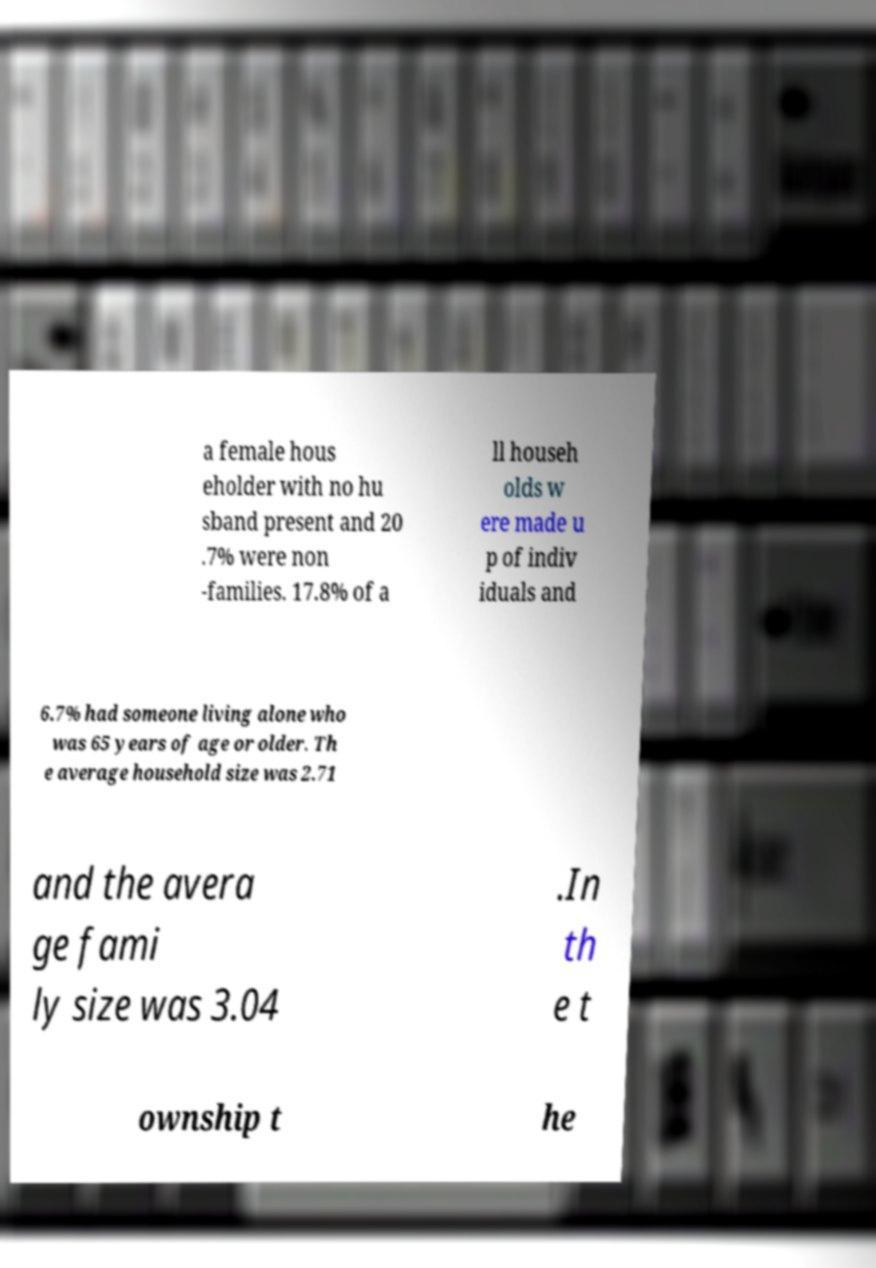Could you assist in decoding the text presented in this image and type it out clearly? a female hous eholder with no hu sband present and 20 .7% were non -families. 17.8% of a ll househ olds w ere made u p of indiv iduals and 6.7% had someone living alone who was 65 years of age or older. Th e average household size was 2.71 and the avera ge fami ly size was 3.04 .In th e t ownship t he 